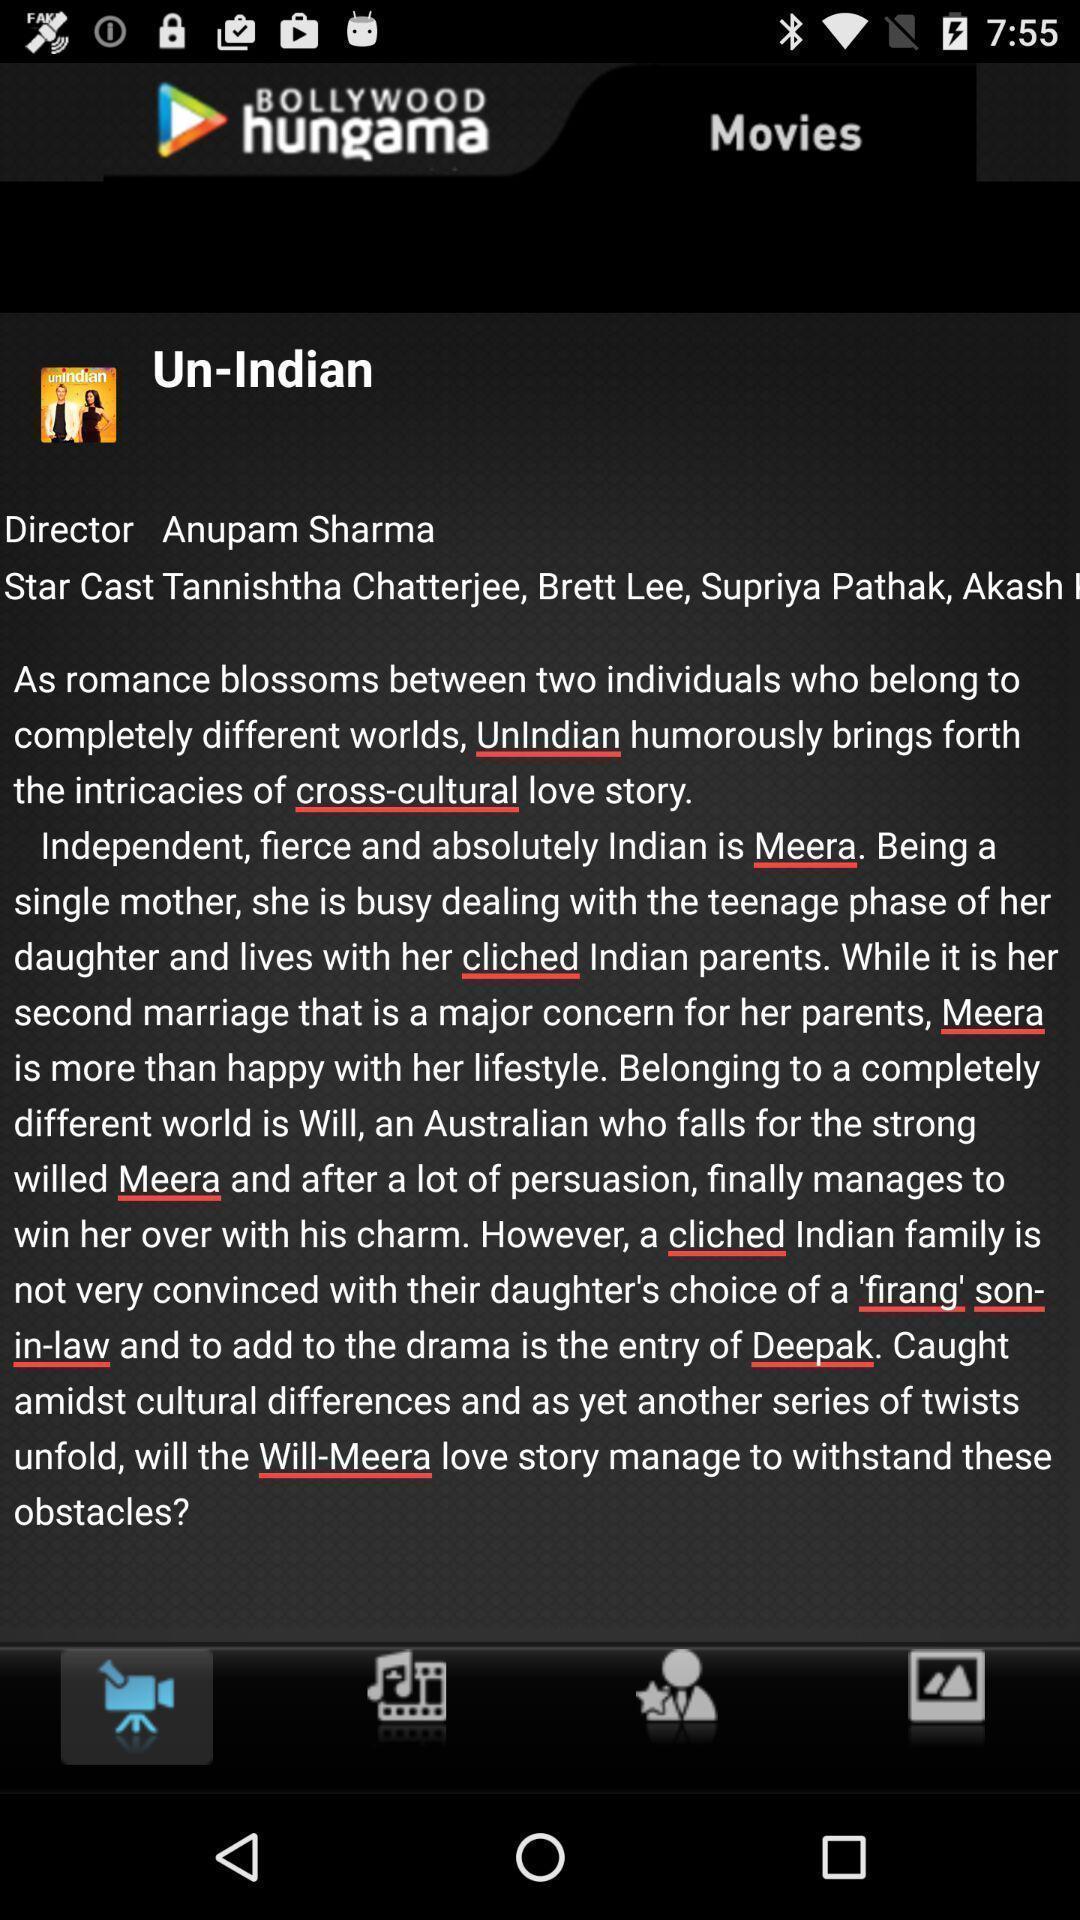Explain what's happening in this screen capture. Screen showing information. 